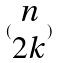Convert formula to latex. <formula><loc_0><loc_0><loc_500><loc_500>( \begin{matrix} n \\ 2 k \end{matrix} )</formula> 